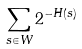Convert formula to latex. <formula><loc_0><loc_0><loc_500><loc_500>\sum _ { s \in W } 2 ^ { - H ( s ) }</formula> 